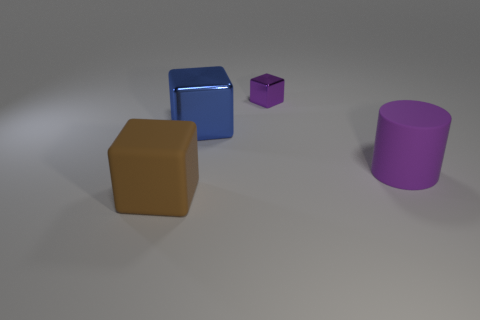Add 2 cyan shiny objects. How many objects exist? 6 Subtract 0 green balls. How many objects are left? 4 Subtract all cubes. How many objects are left? 1 Subtract all big purple matte blocks. Subtract all purple blocks. How many objects are left? 3 Add 1 purple cylinders. How many purple cylinders are left? 2 Add 1 small blue shiny cylinders. How many small blue shiny cylinders exist? 1 